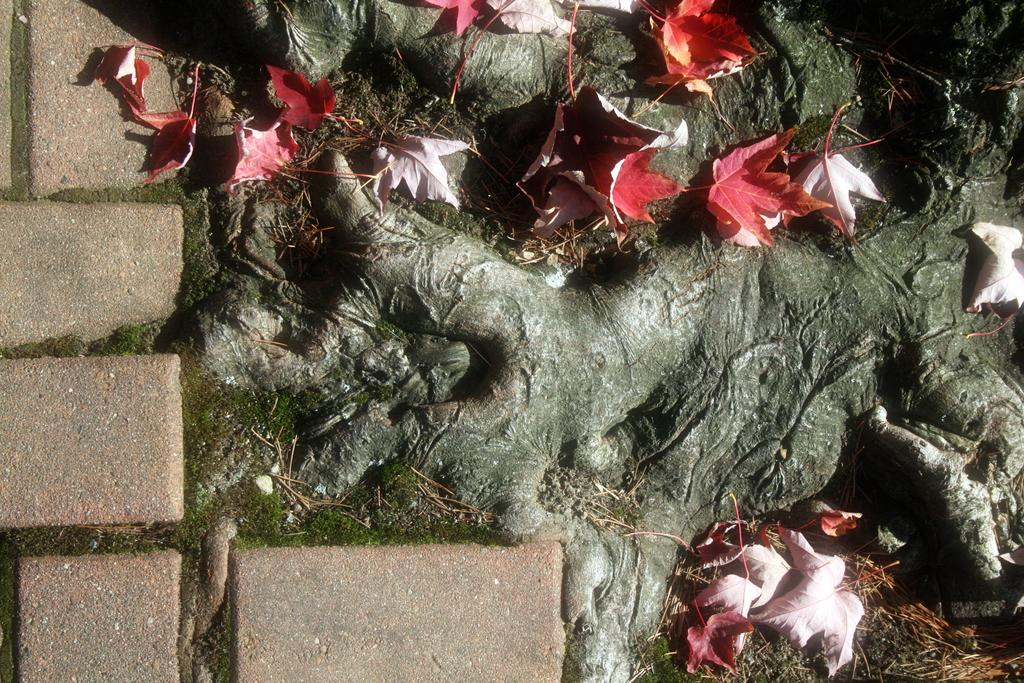What is the main object in the image? There is a tree in the image. Can you describe the color of the tree? The tree is black and grey in color. What is present on the tree? There are leaves on the tree. What colors are the leaves? The leaves are orange, red, and white in color. What else can be seen in the image? The ground is visible in the image. How many crows are sitting on the branches of the tree in the image? There are no crows present in the image; it only features a tree with leaves. 